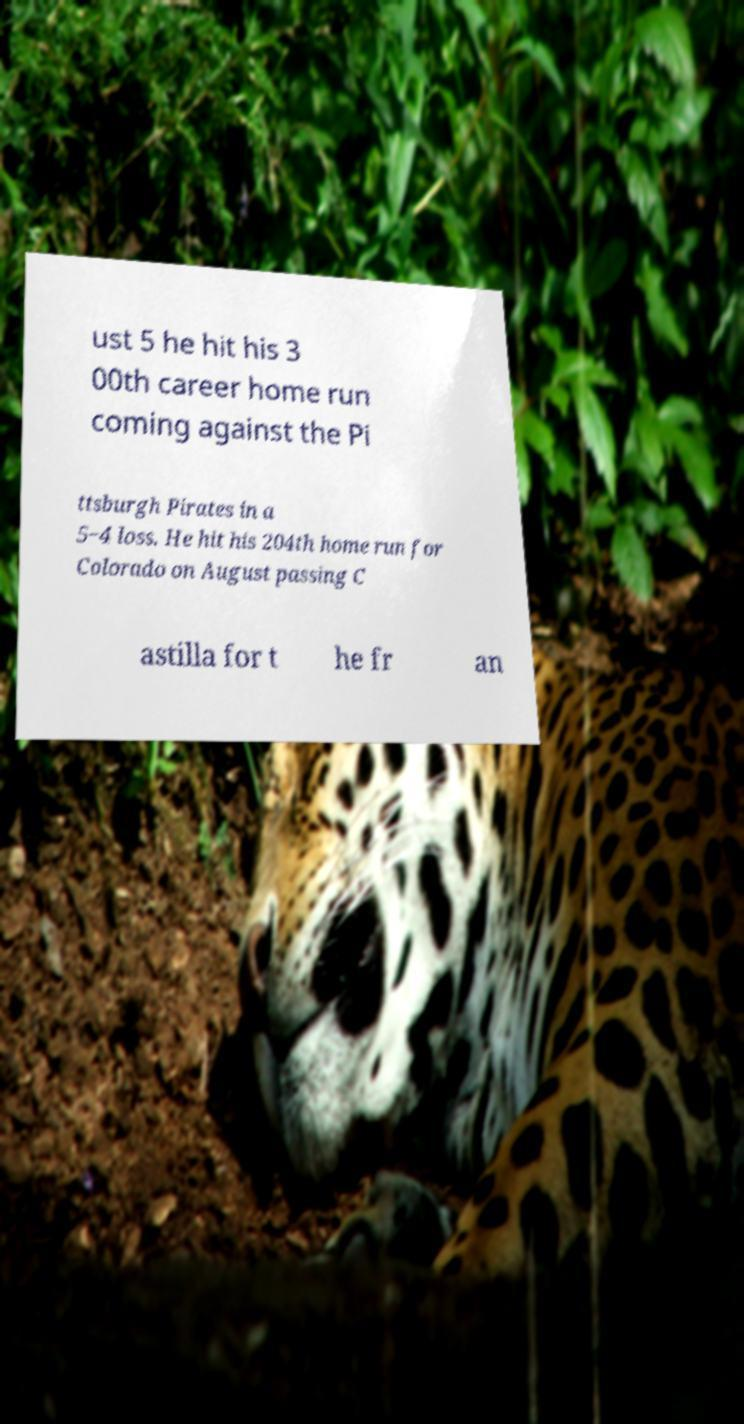Could you extract and type out the text from this image? ust 5 he hit his 3 00th career home run coming against the Pi ttsburgh Pirates in a 5−4 loss. He hit his 204th home run for Colorado on August passing C astilla for t he fr an 